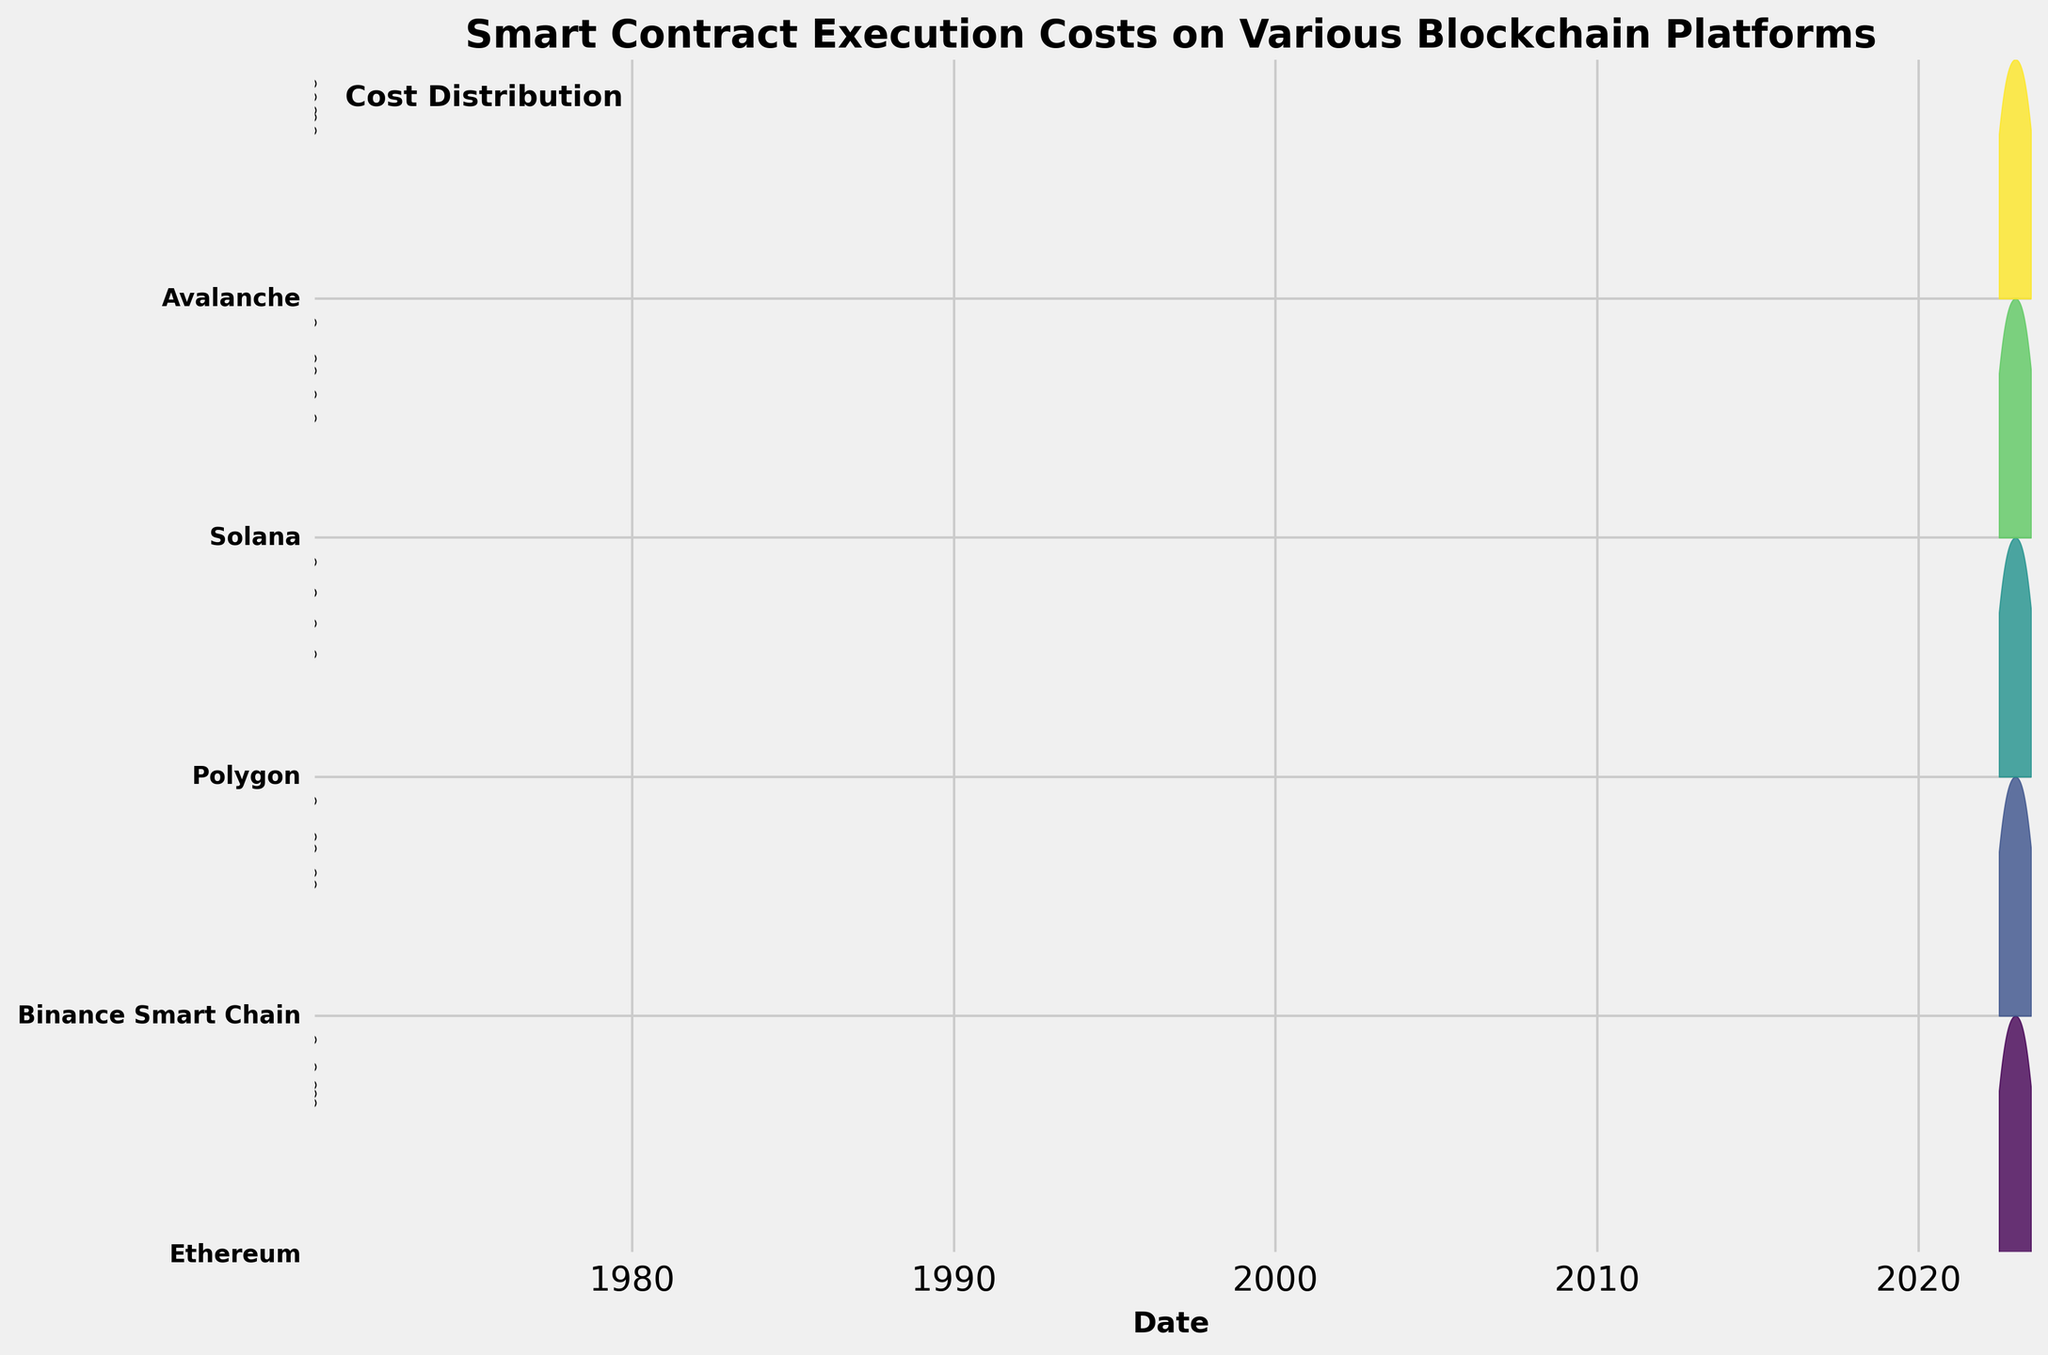What is the title of the figure? The title of the figure is written at the top of the plot. By reading, we find that it is "Smart Contract Execution Costs on Various Blockchain Platforms".
Answer: Smart Contract Execution Costs on Various Blockchain Platforms How many different blockchain platforms are represented in the plot? The plot uses different levels of the y-axis to represent each blockchain platform. By counting the unique labels on the y-axis, we find there are five different platforms.
Answer: Five Which blockchain platform had the highest smart contract execution cost on the latest date shown in the figure? To determine this, look at the rightmost data points for each blockchain on the x-axis and compare their heights. "Ethereum" has the highest point on the far right.
Answer: Ethereum What is the pattern of smart contract execution cost for Solana over the past year? Check the points plotted for Solana across the timeline and observe their heights relative to each other. Solana has consistently low costs fluctuating slightly.
Answer: Consistently low, slight fluctuations Which blockchain has the most densely packed cost data points over the past year? To determine this, look at the density and clustering of data points along the x-axis for each blockchain. "Avalanche" and "Binance Smart Chain" show dense clustering.
Answer: Avalanche and Binance Smart Chain What trend can be observed for Polygon's smart contract execution costs over the past year? Examine the points and filled areas for Polygon. Polygon's costs hover very low but slightly increased between some periods before returning towards their initial value.
Answer: Slight increase then stabilization Which blockchain platform showed the greatest variability in smart contract execution costs? To observe variability, look at the spread and range of the filled curves for each blockchain. "Ethereum" exhibits the widest spread, indicating high variability.
Answer: Ethereum Were there any periods where the smart contract execution costs for Avalanche increased? Observe the timeline and the corresponding heights of the data points for Avalanche. Costs increased between July 2022 and April 2023.
Answer: Yes, from July 2022 to April 2023 